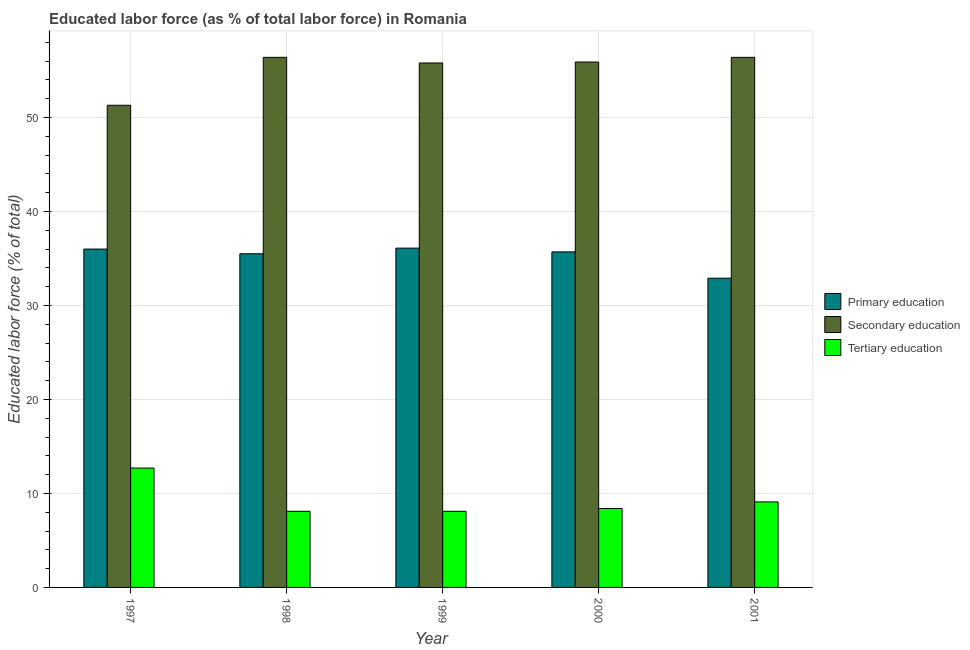How many different coloured bars are there?
Provide a short and direct response. 3. How many groups of bars are there?
Your answer should be compact. 5. How many bars are there on the 5th tick from the left?
Provide a succinct answer. 3. What is the label of the 2nd group of bars from the left?
Provide a short and direct response. 1998. In how many cases, is the number of bars for a given year not equal to the number of legend labels?
Offer a terse response. 0. What is the percentage of labor force who received secondary education in 1997?
Provide a succinct answer. 51.3. Across all years, what is the maximum percentage of labor force who received primary education?
Make the answer very short. 36.1. Across all years, what is the minimum percentage of labor force who received primary education?
Your response must be concise. 32.9. In which year was the percentage of labor force who received secondary education minimum?
Your response must be concise. 1997. What is the total percentage of labor force who received secondary education in the graph?
Keep it short and to the point. 275.8. What is the difference between the percentage of labor force who received primary education in 1997 and the percentage of labor force who received tertiary education in 1998?
Offer a very short reply. 0.5. What is the average percentage of labor force who received secondary education per year?
Offer a terse response. 55.16. Is the percentage of labor force who received tertiary education in 1999 less than that in 2001?
Your answer should be compact. Yes. What is the difference between the highest and the second highest percentage of labor force who received primary education?
Make the answer very short. 0.1. What is the difference between the highest and the lowest percentage of labor force who received primary education?
Your answer should be compact. 3.2. Is the sum of the percentage of labor force who received tertiary education in 1998 and 2000 greater than the maximum percentage of labor force who received secondary education across all years?
Keep it short and to the point. Yes. What does the 2nd bar from the left in 2001 represents?
Your response must be concise. Secondary education. What does the 2nd bar from the right in 2001 represents?
Your response must be concise. Secondary education. How many bars are there?
Offer a terse response. 15. Does the graph contain any zero values?
Offer a terse response. No. Does the graph contain grids?
Offer a terse response. Yes. Where does the legend appear in the graph?
Offer a very short reply. Center right. What is the title of the graph?
Provide a succinct answer. Educated labor force (as % of total labor force) in Romania. What is the label or title of the Y-axis?
Ensure brevity in your answer.  Educated labor force (% of total). What is the Educated labor force (% of total) in Secondary education in 1997?
Ensure brevity in your answer.  51.3. What is the Educated labor force (% of total) in Tertiary education in 1997?
Your answer should be compact. 12.7. What is the Educated labor force (% of total) in Primary education in 1998?
Give a very brief answer. 35.5. What is the Educated labor force (% of total) in Secondary education in 1998?
Keep it short and to the point. 56.4. What is the Educated labor force (% of total) in Tertiary education in 1998?
Offer a terse response. 8.1. What is the Educated labor force (% of total) in Primary education in 1999?
Offer a very short reply. 36.1. What is the Educated labor force (% of total) in Secondary education in 1999?
Your response must be concise. 55.8. What is the Educated labor force (% of total) in Tertiary education in 1999?
Provide a succinct answer. 8.1. What is the Educated labor force (% of total) of Primary education in 2000?
Offer a very short reply. 35.7. What is the Educated labor force (% of total) of Secondary education in 2000?
Your answer should be compact. 55.9. What is the Educated labor force (% of total) in Tertiary education in 2000?
Provide a succinct answer. 8.4. What is the Educated labor force (% of total) in Primary education in 2001?
Provide a short and direct response. 32.9. What is the Educated labor force (% of total) of Secondary education in 2001?
Your answer should be compact. 56.4. What is the Educated labor force (% of total) in Tertiary education in 2001?
Provide a succinct answer. 9.1. Across all years, what is the maximum Educated labor force (% of total) of Primary education?
Your answer should be compact. 36.1. Across all years, what is the maximum Educated labor force (% of total) of Secondary education?
Offer a terse response. 56.4. Across all years, what is the maximum Educated labor force (% of total) of Tertiary education?
Offer a very short reply. 12.7. Across all years, what is the minimum Educated labor force (% of total) of Primary education?
Provide a short and direct response. 32.9. Across all years, what is the minimum Educated labor force (% of total) in Secondary education?
Provide a short and direct response. 51.3. Across all years, what is the minimum Educated labor force (% of total) in Tertiary education?
Provide a succinct answer. 8.1. What is the total Educated labor force (% of total) of Primary education in the graph?
Provide a succinct answer. 176.2. What is the total Educated labor force (% of total) of Secondary education in the graph?
Ensure brevity in your answer.  275.8. What is the total Educated labor force (% of total) in Tertiary education in the graph?
Keep it short and to the point. 46.4. What is the difference between the Educated labor force (% of total) in Tertiary education in 1997 and that in 1998?
Your response must be concise. 4.6. What is the difference between the Educated labor force (% of total) of Primary education in 1997 and that in 1999?
Your answer should be very brief. -0.1. What is the difference between the Educated labor force (% of total) of Secondary education in 1997 and that in 1999?
Your answer should be very brief. -4.5. What is the difference between the Educated labor force (% of total) of Tertiary education in 1997 and that in 2000?
Ensure brevity in your answer.  4.3. What is the difference between the Educated labor force (% of total) of Tertiary education in 1997 and that in 2001?
Your answer should be compact. 3.6. What is the difference between the Educated labor force (% of total) in Primary education in 1998 and that in 2000?
Offer a very short reply. -0.2. What is the difference between the Educated labor force (% of total) in Primary education in 1998 and that in 2001?
Offer a terse response. 2.6. What is the difference between the Educated labor force (% of total) of Tertiary education in 1999 and that in 2000?
Offer a terse response. -0.3. What is the difference between the Educated labor force (% of total) in Secondary education in 1999 and that in 2001?
Keep it short and to the point. -0.6. What is the difference between the Educated labor force (% of total) of Tertiary education in 1999 and that in 2001?
Offer a very short reply. -1. What is the difference between the Educated labor force (% of total) in Primary education in 2000 and that in 2001?
Provide a short and direct response. 2.8. What is the difference between the Educated labor force (% of total) of Secondary education in 2000 and that in 2001?
Ensure brevity in your answer.  -0.5. What is the difference between the Educated labor force (% of total) in Tertiary education in 2000 and that in 2001?
Your answer should be very brief. -0.7. What is the difference between the Educated labor force (% of total) in Primary education in 1997 and the Educated labor force (% of total) in Secondary education in 1998?
Give a very brief answer. -20.4. What is the difference between the Educated labor force (% of total) in Primary education in 1997 and the Educated labor force (% of total) in Tertiary education in 1998?
Make the answer very short. 27.9. What is the difference between the Educated labor force (% of total) in Secondary education in 1997 and the Educated labor force (% of total) in Tertiary education in 1998?
Give a very brief answer. 43.2. What is the difference between the Educated labor force (% of total) of Primary education in 1997 and the Educated labor force (% of total) of Secondary education in 1999?
Keep it short and to the point. -19.8. What is the difference between the Educated labor force (% of total) in Primary education in 1997 and the Educated labor force (% of total) in Tertiary education in 1999?
Make the answer very short. 27.9. What is the difference between the Educated labor force (% of total) in Secondary education in 1997 and the Educated labor force (% of total) in Tertiary education in 1999?
Give a very brief answer. 43.2. What is the difference between the Educated labor force (% of total) of Primary education in 1997 and the Educated labor force (% of total) of Secondary education in 2000?
Provide a succinct answer. -19.9. What is the difference between the Educated labor force (% of total) of Primary education in 1997 and the Educated labor force (% of total) of Tertiary education in 2000?
Provide a short and direct response. 27.6. What is the difference between the Educated labor force (% of total) of Secondary education in 1997 and the Educated labor force (% of total) of Tertiary education in 2000?
Ensure brevity in your answer.  42.9. What is the difference between the Educated labor force (% of total) of Primary education in 1997 and the Educated labor force (% of total) of Secondary education in 2001?
Your answer should be very brief. -20.4. What is the difference between the Educated labor force (% of total) of Primary education in 1997 and the Educated labor force (% of total) of Tertiary education in 2001?
Make the answer very short. 26.9. What is the difference between the Educated labor force (% of total) in Secondary education in 1997 and the Educated labor force (% of total) in Tertiary education in 2001?
Ensure brevity in your answer.  42.2. What is the difference between the Educated labor force (% of total) of Primary education in 1998 and the Educated labor force (% of total) of Secondary education in 1999?
Your answer should be very brief. -20.3. What is the difference between the Educated labor force (% of total) of Primary education in 1998 and the Educated labor force (% of total) of Tertiary education in 1999?
Your answer should be compact. 27.4. What is the difference between the Educated labor force (% of total) in Secondary education in 1998 and the Educated labor force (% of total) in Tertiary education in 1999?
Make the answer very short. 48.3. What is the difference between the Educated labor force (% of total) in Primary education in 1998 and the Educated labor force (% of total) in Secondary education in 2000?
Keep it short and to the point. -20.4. What is the difference between the Educated labor force (% of total) in Primary education in 1998 and the Educated labor force (% of total) in Tertiary education in 2000?
Your answer should be compact. 27.1. What is the difference between the Educated labor force (% of total) in Primary education in 1998 and the Educated labor force (% of total) in Secondary education in 2001?
Keep it short and to the point. -20.9. What is the difference between the Educated labor force (% of total) in Primary education in 1998 and the Educated labor force (% of total) in Tertiary education in 2001?
Your answer should be very brief. 26.4. What is the difference between the Educated labor force (% of total) in Secondary education in 1998 and the Educated labor force (% of total) in Tertiary education in 2001?
Keep it short and to the point. 47.3. What is the difference between the Educated labor force (% of total) in Primary education in 1999 and the Educated labor force (% of total) in Secondary education in 2000?
Offer a terse response. -19.8. What is the difference between the Educated labor force (% of total) of Primary education in 1999 and the Educated labor force (% of total) of Tertiary education in 2000?
Ensure brevity in your answer.  27.7. What is the difference between the Educated labor force (% of total) in Secondary education in 1999 and the Educated labor force (% of total) in Tertiary education in 2000?
Give a very brief answer. 47.4. What is the difference between the Educated labor force (% of total) in Primary education in 1999 and the Educated labor force (% of total) in Secondary education in 2001?
Ensure brevity in your answer.  -20.3. What is the difference between the Educated labor force (% of total) in Primary education in 1999 and the Educated labor force (% of total) in Tertiary education in 2001?
Offer a terse response. 27. What is the difference between the Educated labor force (% of total) in Secondary education in 1999 and the Educated labor force (% of total) in Tertiary education in 2001?
Offer a terse response. 46.7. What is the difference between the Educated labor force (% of total) in Primary education in 2000 and the Educated labor force (% of total) in Secondary education in 2001?
Your answer should be very brief. -20.7. What is the difference between the Educated labor force (% of total) of Primary education in 2000 and the Educated labor force (% of total) of Tertiary education in 2001?
Offer a terse response. 26.6. What is the difference between the Educated labor force (% of total) of Secondary education in 2000 and the Educated labor force (% of total) of Tertiary education in 2001?
Your answer should be very brief. 46.8. What is the average Educated labor force (% of total) in Primary education per year?
Keep it short and to the point. 35.24. What is the average Educated labor force (% of total) in Secondary education per year?
Offer a very short reply. 55.16. What is the average Educated labor force (% of total) in Tertiary education per year?
Give a very brief answer. 9.28. In the year 1997, what is the difference between the Educated labor force (% of total) of Primary education and Educated labor force (% of total) of Secondary education?
Your response must be concise. -15.3. In the year 1997, what is the difference between the Educated labor force (% of total) of Primary education and Educated labor force (% of total) of Tertiary education?
Make the answer very short. 23.3. In the year 1997, what is the difference between the Educated labor force (% of total) in Secondary education and Educated labor force (% of total) in Tertiary education?
Your answer should be very brief. 38.6. In the year 1998, what is the difference between the Educated labor force (% of total) of Primary education and Educated labor force (% of total) of Secondary education?
Offer a terse response. -20.9. In the year 1998, what is the difference between the Educated labor force (% of total) in Primary education and Educated labor force (% of total) in Tertiary education?
Provide a succinct answer. 27.4. In the year 1998, what is the difference between the Educated labor force (% of total) of Secondary education and Educated labor force (% of total) of Tertiary education?
Your answer should be compact. 48.3. In the year 1999, what is the difference between the Educated labor force (% of total) in Primary education and Educated labor force (% of total) in Secondary education?
Provide a succinct answer. -19.7. In the year 1999, what is the difference between the Educated labor force (% of total) in Secondary education and Educated labor force (% of total) in Tertiary education?
Ensure brevity in your answer.  47.7. In the year 2000, what is the difference between the Educated labor force (% of total) in Primary education and Educated labor force (% of total) in Secondary education?
Keep it short and to the point. -20.2. In the year 2000, what is the difference between the Educated labor force (% of total) in Primary education and Educated labor force (% of total) in Tertiary education?
Your answer should be very brief. 27.3. In the year 2000, what is the difference between the Educated labor force (% of total) of Secondary education and Educated labor force (% of total) of Tertiary education?
Keep it short and to the point. 47.5. In the year 2001, what is the difference between the Educated labor force (% of total) in Primary education and Educated labor force (% of total) in Secondary education?
Provide a short and direct response. -23.5. In the year 2001, what is the difference between the Educated labor force (% of total) of Primary education and Educated labor force (% of total) of Tertiary education?
Offer a terse response. 23.8. In the year 2001, what is the difference between the Educated labor force (% of total) of Secondary education and Educated labor force (% of total) of Tertiary education?
Offer a very short reply. 47.3. What is the ratio of the Educated labor force (% of total) of Primary education in 1997 to that in 1998?
Offer a terse response. 1.01. What is the ratio of the Educated labor force (% of total) of Secondary education in 1997 to that in 1998?
Your answer should be compact. 0.91. What is the ratio of the Educated labor force (% of total) in Tertiary education in 1997 to that in 1998?
Your answer should be compact. 1.57. What is the ratio of the Educated labor force (% of total) in Secondary education in 1997 to that in 1999?
Keep it short and to the point. 0.92. What is the ratio of the Educated labor force (% of total) in Tertiary education in 1997 to that in 1999?
Offer a very short reply. 1.57. What is the ratio of the Educated labor force (% of total) of Primary education in 1997 to that in 2000?
Provide a succinct answer. 1.01. What is the ratio of the Educated labor force (% of total) of Secondary education in 1997 to that in 2000?
Your response must be concise. 0.92. What is the ratio of the Educated labor force (% of total) of Tertiary education in 1997 to that in 2000?
Your response must be concise. 1.51. What is the ratio of the Educated labor force (% of total) of Primary education in 1997 to that in 2001?
Your response must be concise. 1.09. What is the ratio of the Educated labor force (% of total) in Secondary education in 1997 to that in 2001?
Provide a short and direct response. 0.91. What is the ratio of the Educated labor force (% of total) in Tertiary education in 1997 to that in 2001?
Provide a short and direct response. 1.4. What is the ratio of the Educated labor force (% of total) of Primary education in 1998 to that in 1999?
Make the answer very short. 0.98. What is the ratio of the Educated labor force (% of total) in Secondary education in 1998 to that in 1999?
Ensure brevity in your answer.  1.01. What is the ratio of the Educated labor force (% of total) in Tertiary education in 1998 to that in 1999?
Offer a very short reply. 1. What is the ratio of the Educated labor force (% of total) in Primary education in 1998 to that in 2000?
Your answer should be compact. 0.99. What is the ratio of the Educated labor force (% of total) of Secondary education in 1998 to that in 2000?
Your answer should be very brief. 1.01. What is the ratio of the Educated labor force (% of total) of Tertiary education in 1998 to that in 2000?
Provide a succinct answer. 0.96. What is the ratio of the Educated labor force (% of total) of Primary education in 1998 to that in 2001?
Provide a short and direct response. 1.08. What is the ratio of the Educated labor force (% of total) in Secondary education in 1998 to that in 2001?
Offer a terse response. 1. What is the ratio of the Educated labor force (% of total) in Tertiary education in 1998 to that in 2001?
Ensure brevity in your answer.  0.89. What is the ratio of the Educated labor force (% of total) in Primary education in 1999 to that in 2000?
Your answer should be very brief. 1.01. What is the ratio of the Educated labor force (% of total) of Tertiary education in 1999 to that in 2000?
Give a very brief answer. 0.96. What is the ratio of the Educated labor force (% of total) in Primary education in 1999 to that in 2001?
Provide a succinct answer. 1.1. What is the ratio of the Educated labor force (% of total) in Tertiary education in 1999 to that in 2001?
Make the answer very short. 0.89. What is the ratio of the Educated labor force (% of total) in Primary education in 2000 to that in 2001?
Provide a short and direct response. 1.09. What is the difference between the highest and the lowest Educated labor force (% of total) of Primary education?
Your response must be concise. 3.2. 